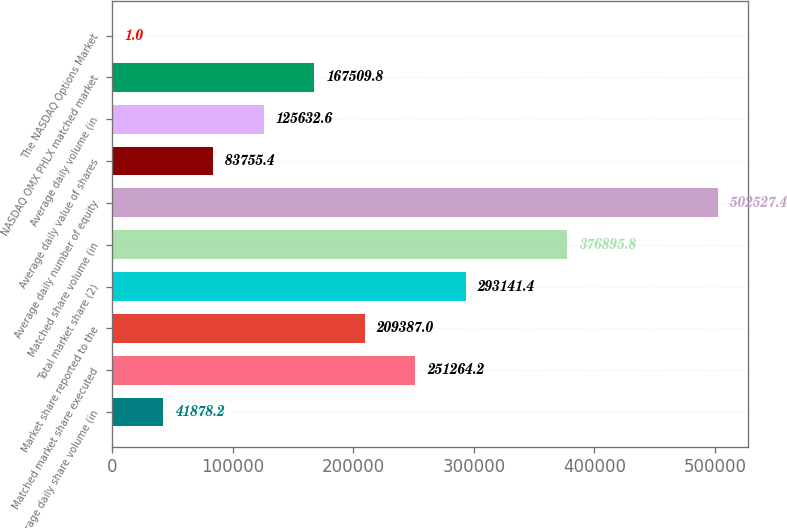Convert chart. <chart><loc_0><loc_0><loc_500><loc_500><bar_chart><fcel>Average daily share volume (in<fcel>Matched market share executed<fcel>Market share reported to the<fcel>Total market share (2)<fcel>Matched share volume (in<fcel>Average daily number of equity<fcel>Average daily value of shares<fcel>Average daily volume (in<fcel>NASDAQ OMX PHLX matched market<fcel>The NASDAQ Options Market<nl><fcel>41878.2<fcel>251264<fcel>209387<fcel>293141<fcel>376896<fcel>502527<fcel>83755.4<fcel>125633<fcel>167510<fcel>1<nl></chart> 